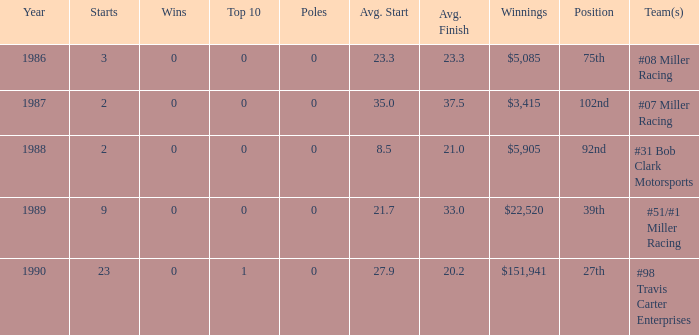What are the poles is #08 Miller racing? 0.0. 